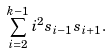Convert formula to latex. <formula><loc_0><loc_0><loc_500><loc_500>\sum _ { i = 2 } ^ { k - 1 } i ^ { 2 } s _ { i - 1 } s _ { i + 1 } .</formula> 